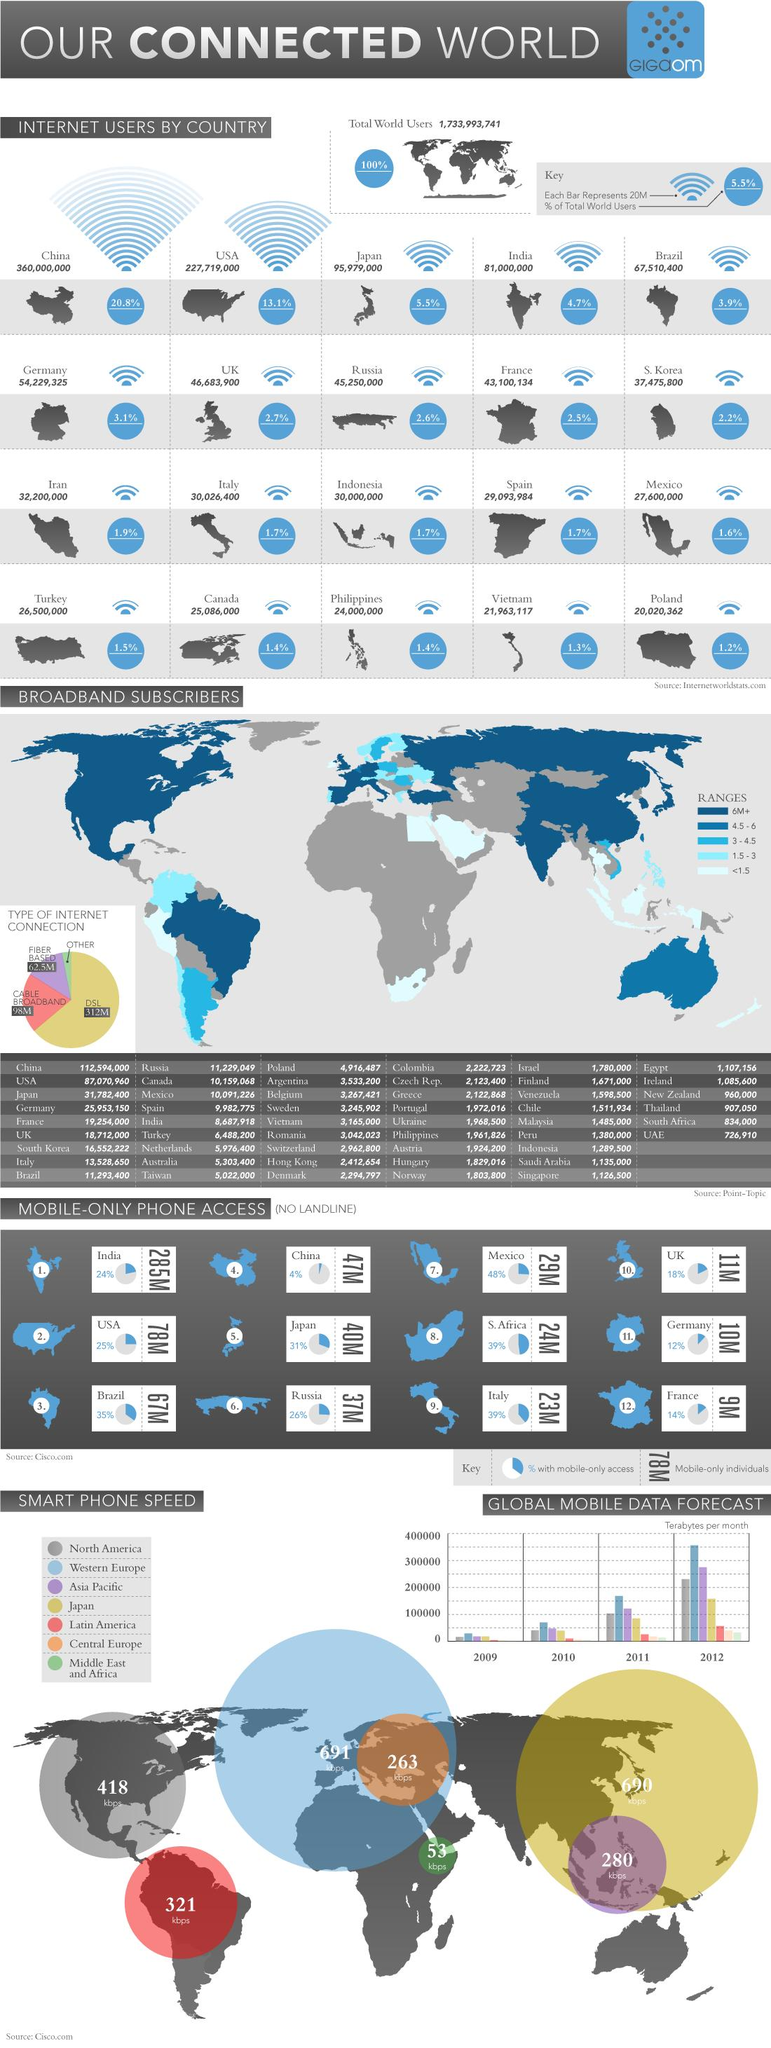Outline some significant characteristics in this image. The average speed of smartphones in Latin America is 321 kilobits per second. Out of all the users worldwide, approximately 5.5% are located in Japan. India has the fourth highest percentage of total world users. Japan has the second highest smartphone speeds among all countries. According to data, the United States and Canada together account for approximately 14.5% of the total number of worldwide users. 